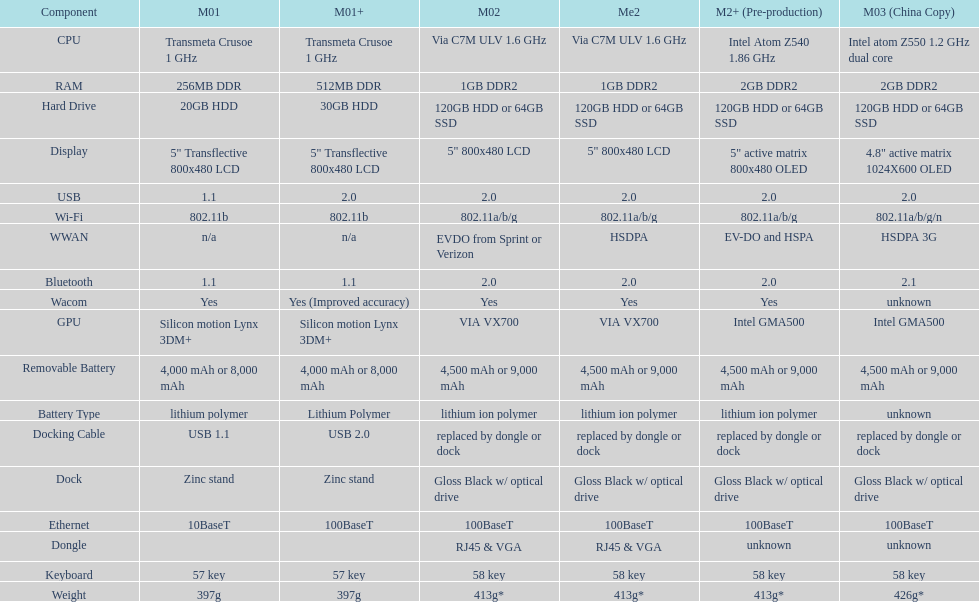How much more weight does the model 3 have over model 1? 29g. Give me the full table as a dictionary. {'header': ['Component', 'M01', 'M01+', 'M02', 'Me2', 'M2+ (Pre-production)', 'M03 (China Copy)'], 'rows': [['CPU', 'Transmeta Crusoe 1\xa0GHz', 'Transmeta Crusoe 1\xa0GHz', 'Via C7M ULV 1.6\xa0GHz', 'Via C7M ULV 1.6\xa0GHz', 'Intel Atom Z540 1.86\xa0GHz', 'Intel atom Z550 1.2\xa0GHz dual core'], ['RAM', '256MB DDR', '512MB DDR', '1GB DDR2', '1GB DDR2', '2GB DDR2', '2GB DDR2'], ['Hard Drive', '20GB HDD', '30GB HDD', '120GB HDD or 64GB SSD', '120GB HDD or 64GB SSD', '120GB HDD or 64GB SSD', '120GB HDD or 64GB SSD'], ['Display', '5" Transflective 800x480 LCD', '5" Transflective 800x480 LCD', '5" 800x480 LCD', '5" 800x480 LCD', '5" active matrix 800x480 OLED', '4.8" active matrix 1024X600 OLED'], ['USB', '1.1', '2.0', '2.0', '2.0', '2.0', '2.0'], ['Wi-Fi', '802.11b', '802.11b', '802.11a/b/g', '802.11a/b/g', '802.11a/b/g', '802.11a/b/g/n'], ['WWAN', 'n/a', 'n/a', 'EVDO from Sprint or Verizon', 'HSDPA', 'EV-DO and HSPA', 'HSDPA 3G'], ['Bluetooth', '1.1', '1.1', '2.0', '2.0', '2.0', '2.1'], ['Wacom', 'Yes', 'Yes (Improved accuracy)', 'Yes', 'Yes', 'Yes', 'unknown'], ['GPU', 'Silicon motion Lynx 3DM+', 'Silicon motion Lynx 3DM+', 'VIA VX700', 'VIA VX700', 'Intel GMA500', 'Intel GMA500'], ['Removable Battery', '4,000 mAh or 8,000 mAh', '4,000 mAh or 8,000 mAh', '4,500 mAh or 9,000 mAh', '4,500 mAh or 9,000 mAh', '4,500 mAh or 9,000 mAh', '4,500 mAh or 9,000 mAh'], ['Battery Type', 'lithium polymer', 'Lithium Polymer', 'lithium ion polymer', 'lithium ion polymer', 'lithium ion polymer', 'unknown'], ['Docking Cable', 'USB 1.1', 'USB 2.0', 'replaced by dongle or dock', 'replaced by dongle or dock', 'replaced by dongle or dock', 'replaced by dongle or dock'], ['Dock', 'Zinc stand', 'Zinc stand', 'Gloss Black w/ optical drive', 'Gloss Black w/ optical drive', 'Gloss Black w/ optical drive', 'Gloss Black w/ optical drive'], ['Ethernet', '10BaseT', '100BaseT', '100BaseT', '100BaseT', '100BaseT', '100BaseT'], ['Dongle', '', '', 'RJ45 & VGA', 'RJ45 & VGA', 'unknown', 'unknown'], ['Keyboard', '57 key', '57 key', '58 key', '58 key', '58 key', '58 key'], ['Weight', '397g', '397g', '413g*', '413g*', '413g*', '426g*']]} 